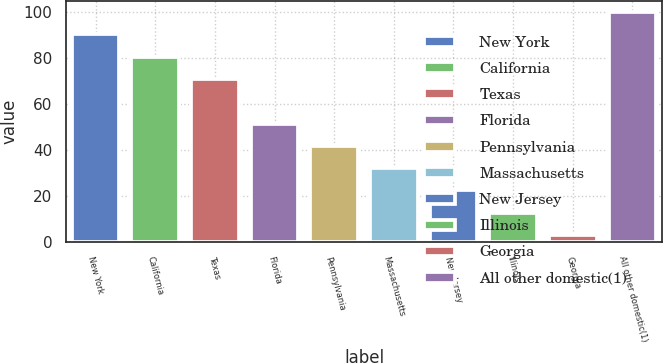Convert chart. <chart><loc_0><loc_0><loc_500><loc_500><bar_chart><fcel>New York<fcel>California<fcel>Texas<fcel>Florida<fcel>Pennsylvania<fcel>Massachusetts<fcel>New Jersey<fcel>Illinois<fcel>Georgia<fcel>All other domestic(1)<nl><fcel>90.31<fcel>80.62<fcel>70.93<fcel>51.55<fcel>41.86<fcel>32.17<fcel>22.48<fcel>12.79<fcel>3.1<fcel>100<nl></chart> 